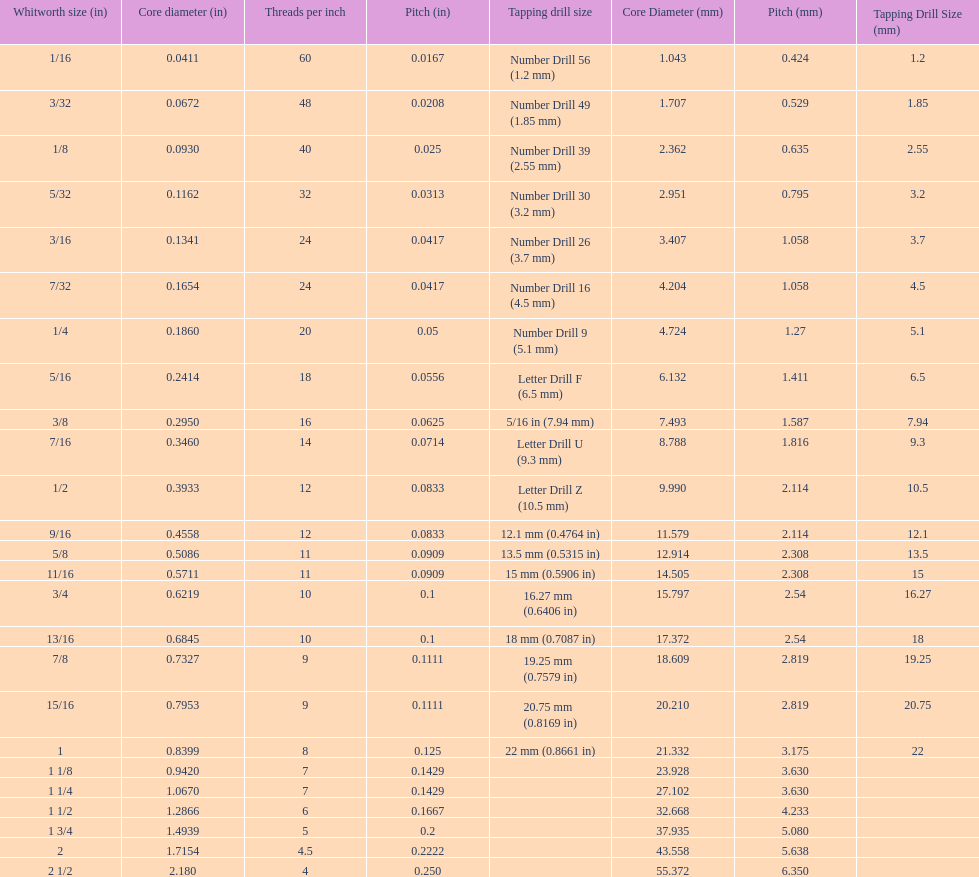What core diameter (in) comes after 0.0930? 0.1162. 